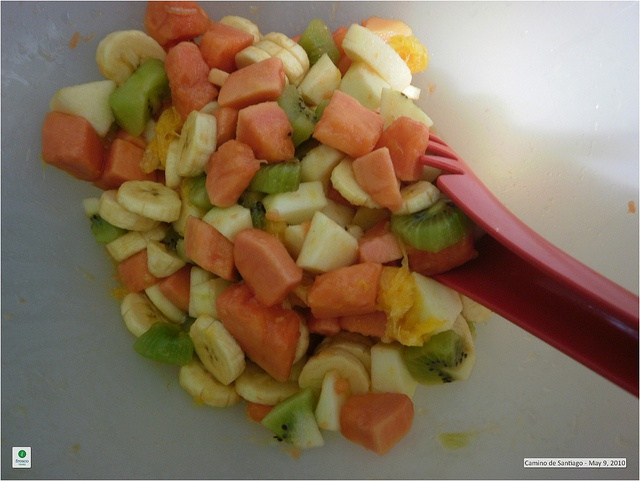Describe the objects in this image and their specific colors. I can see banana in white, olive, and maroon tones, spoon in white, maroon, and brown tones, carrot in white, brown, salmon, and maroon tones, carrot in white, maroon, and brown tones, and carrot in white, brown, and maroon tones in this image. 